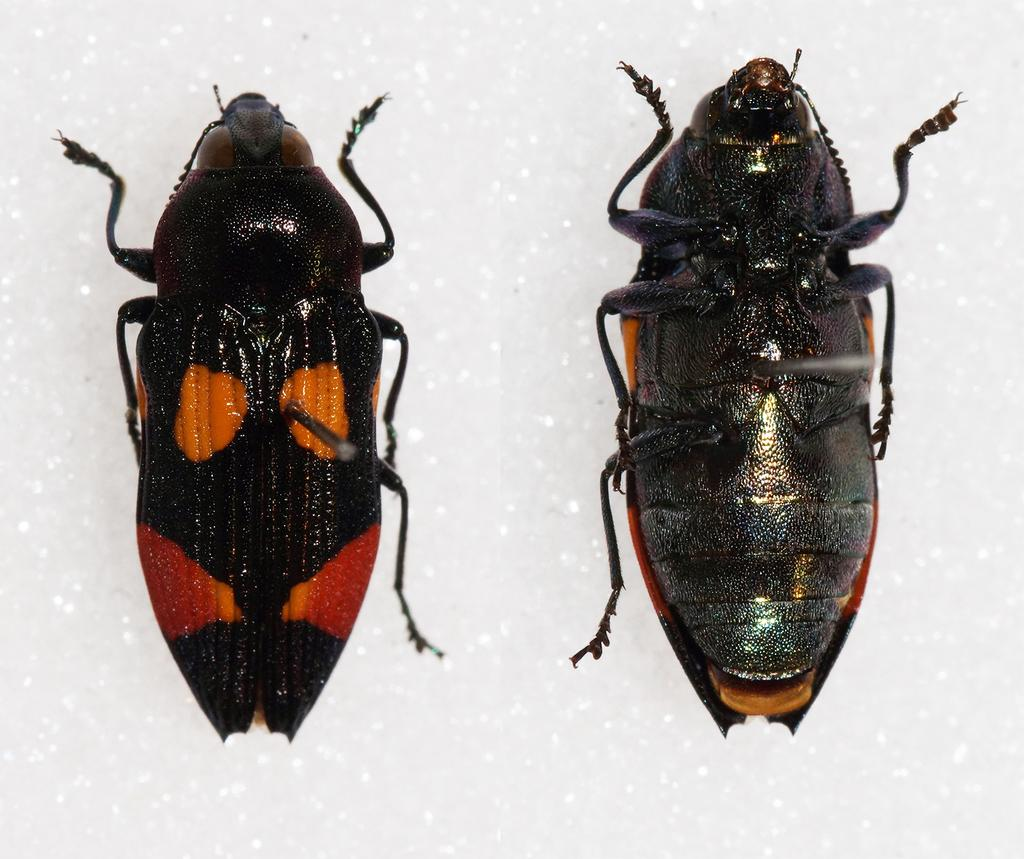How many insects are present in the image? There are two insects in the image. What can be observed about the background of the image? The background of the image is white. What type of bean is being unzipped in the image? There is no bean or zipper present in the image; it only features two insects against a white background. 